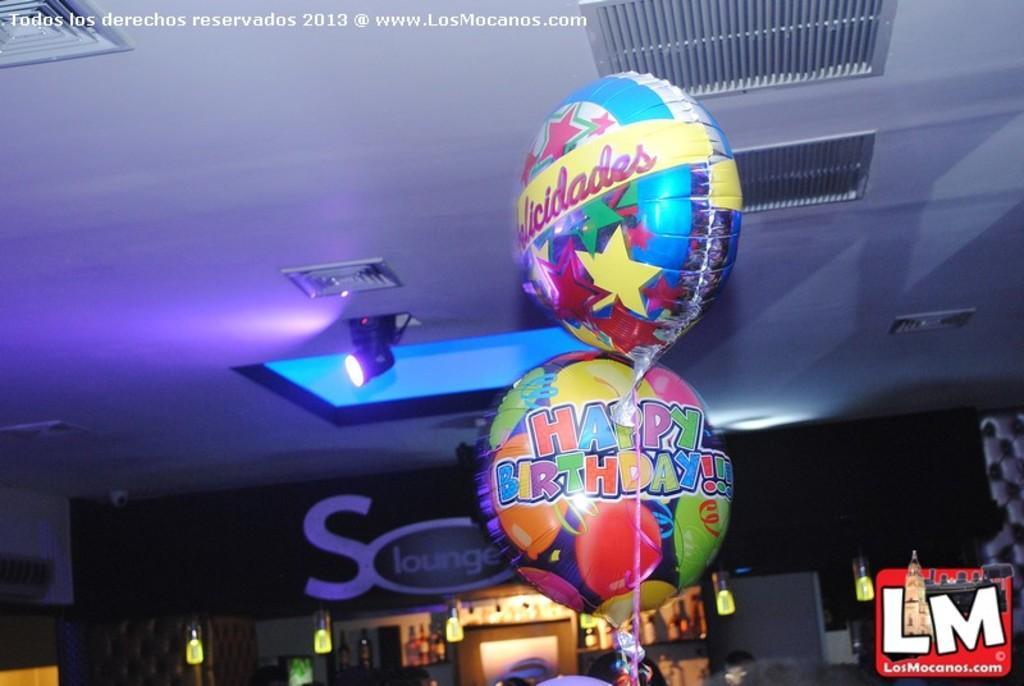In one or two sentences, can you explain what this image depicts? As we can see in the image there is wall, lights, balloons and door. 